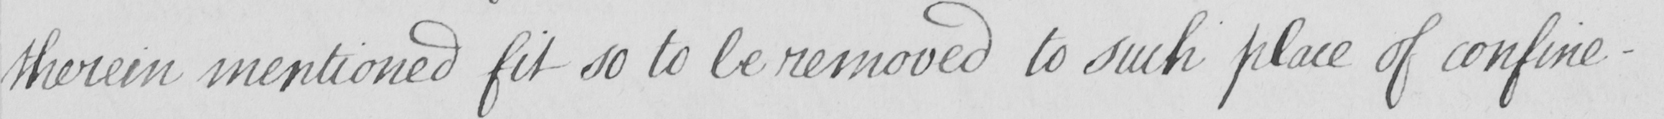Please provide the text content of this handwritten line. therein mentioned fit so to be removed to such place of confine- 